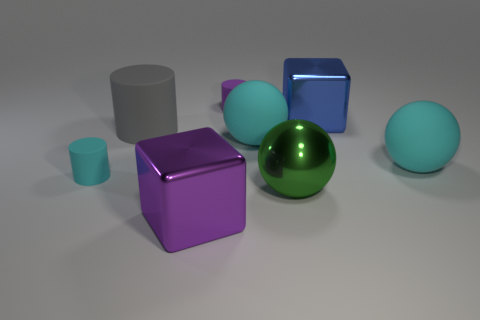Subtract all green cylinders. Subtract all blue cubes. How many cylinders are left? 3 Add 2 large brown objects. How many objects exist? 10 Subtract all cubes. How many objects are left? 6 Add 3 large gray matte cylinders. How many large gray matte cylinders are left? 4 Add 5 big purple matte things. How many big purple matte things exist? 5 Subtract 1 gray cylinders. How many objects are left? 7 Subtract all big purple objects. Subtract all purple metal cubes. How many objects are left? 6 